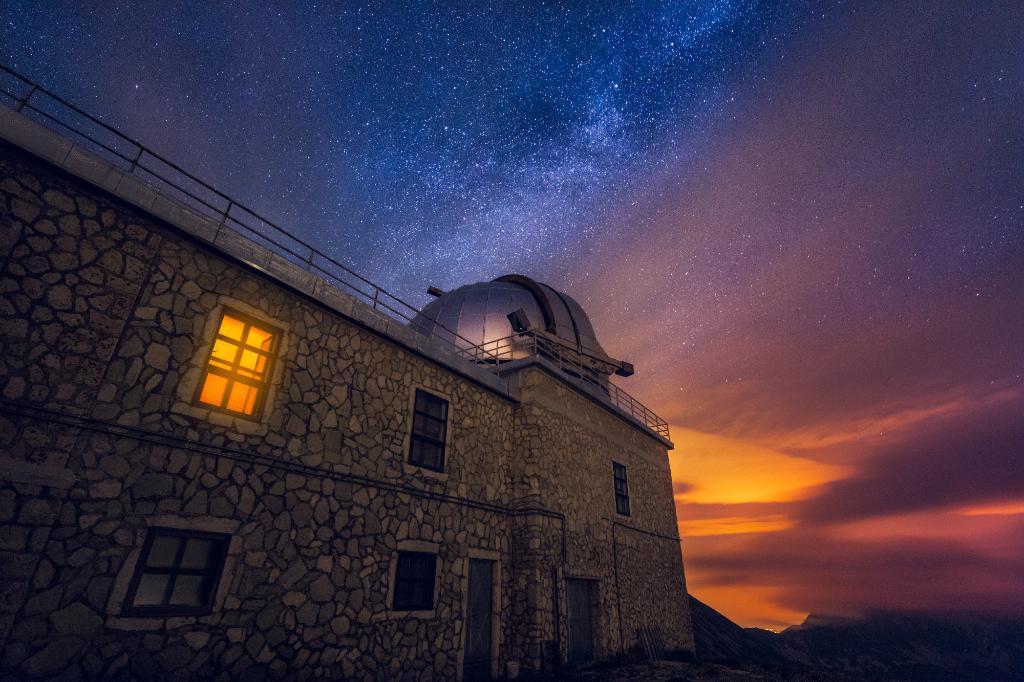Please provide a concise description of this image. In the foreground of the picture there is building, to the building there are windows and door. Sky is colorful. 